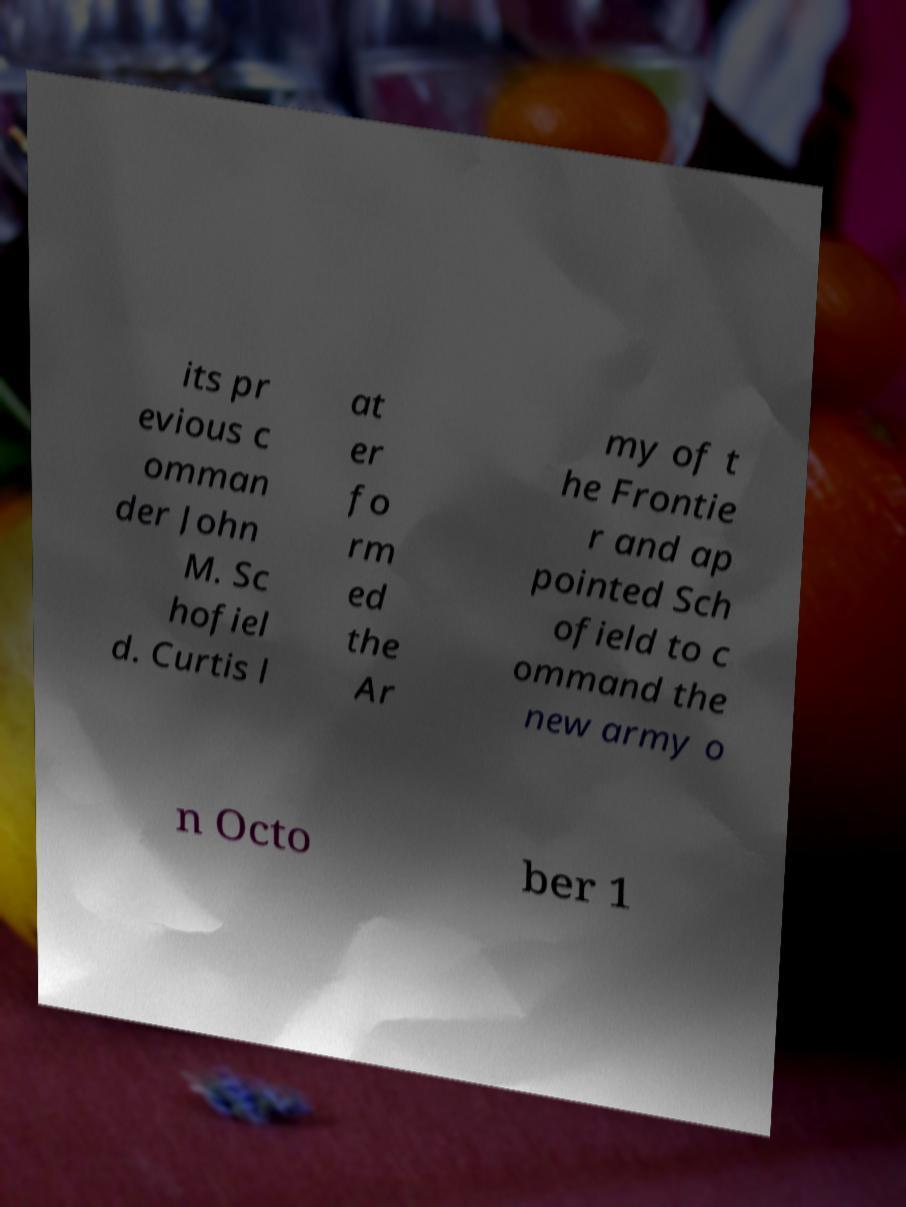The quality of this image is poor; how might one improve readability if they encounter similar issues? To improve the readability of text in a blurry image, one can apply several techniques: using photo editing software to adjust the sharpness, contrast, and brightness; employing optical character recognition (OCR) tools that might interpret the text; or taking a new photo of the document with better lighting and stability to minimize blurriness. 